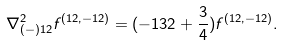Convert formula to latex. <formula><loc_0><loc_0><loc_500><loc_500>\nabla _ { ( - ) 1 2 } ^ { 2 } f ^ { ( 1 2 , - 1 2 ) } = ( - 1 3 2 + \frac { 3 } { 4 } ) f ^ { ( 1 2 , - 1 2 ) } .</formula> 